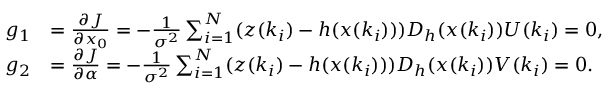Convert formula to latex. <formula><loc_0><loc_0><loc_500><loc_500>\begin{array} { r l } { g _ { 1 } } & { = \frac { \partial J } { \partial x _ { 0 } } = - \frac { 1 } { \sigma ^ { 2 } } \sum _ { i = 1 } ^ { N } ( z ( k _ { i } ) - h ( x ( k _ { i } ) ) ) D _ { h } ( x ( k _ { i } ) ) U ( k _ { i } ) = 0 , } \\ { g _ { 2 } } & { = \frac { \partial J } { \partial \alpha } = - \frac { 1 } { \sigma ^ { 2 } } \sum _ { i = 1 } ^ { N } ( z ( k _ { i } ) - h ( x ( k _ { i } ) ) ) D _ { h } ( x ( k _ { i } ) ) V ( k _ { i } ) = 0 . } \end{array}</formula> 